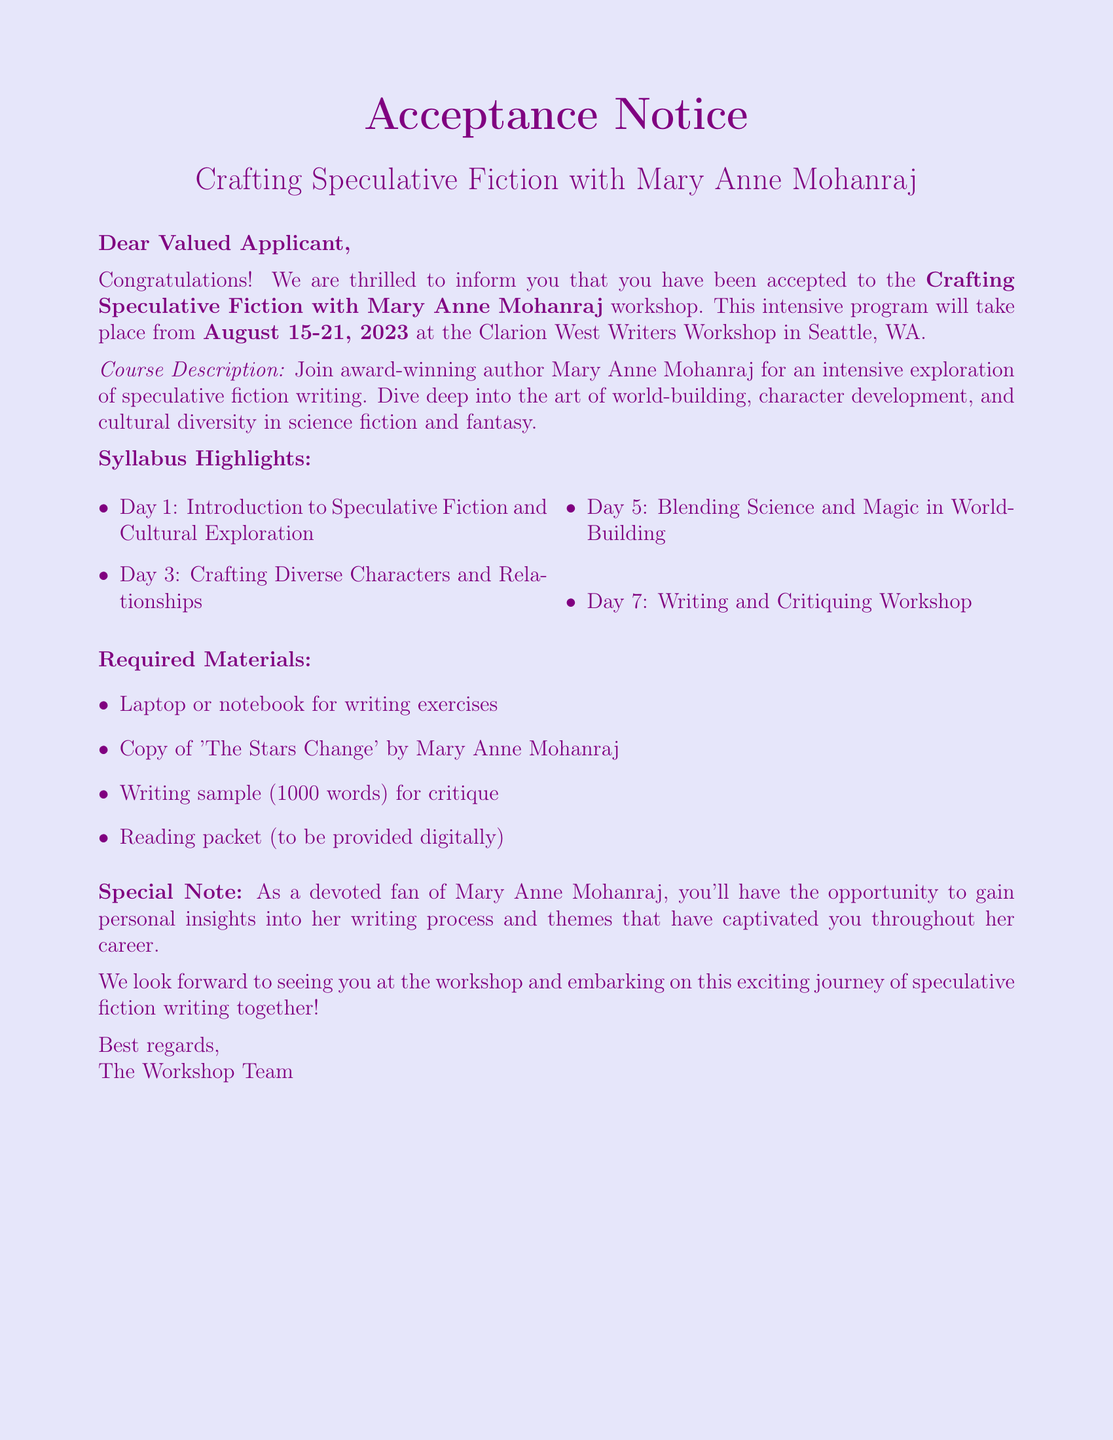What is the name of the workshop? The name of the workshop is stated in the acceptance notice.
Answer: Crafting Speculative Fiction with Mary Anne Mohanraj What are the dates of the workshop? The dates of the workshop are provided clearly in the acceptance notice.
Answer: August 15-21, 2023 Where is the workshop located? The location of the workshop is mentioned in the acceptance notice.
Answer: Clarion West Writers Workshop, Seattle, WA Who is leading the workshop? The acceptance notice specifies the name of the instructor for the workshop.
Answer: Mary Anne Mohanraj What is one topic covered on Day 5? The syllabus highlights provide topics for each day of the workshop.
Answer: Blending Science and Magic in World-Building How many materials are listed as required? The required materials section enumerates the number of items needed.
Answer: Four What is the word limit for the writing sample? The document specifies the length of the writing sample required for critique.
Answer: 1000 words Is there a reading packet provided? The required materials mention the availability of additional reading materials.
Answer: Yes, digitally What special opportunity is mentioned for fans of Mary Anne Mohanraj? The special note highlights what participants may gain from the workshop.
Answer: Personal insights into her writing process and themes 